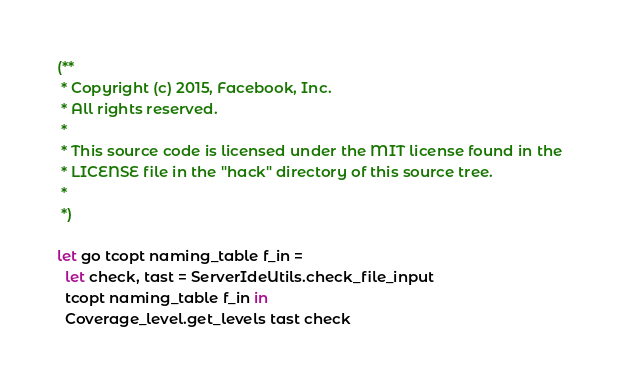Convert code to text. <code><loc_0><loc_0><loc_500><loc_500><_OCaml_>(**
 * Copyright (c) 2015, Facebook, Inc.
 * All rights reserved.
 *
 * This source code is licensed under the MIT license found in the
 * LICENSE file in the "hack" directory of this source tree.
 *
 *)

let go tcopt naming_table f_in =
  let check, tast = ServerIdeUtils.check_file_input
  tcopt naming_table f_in in
  Coverage_level.get_levels tast check
</code> 